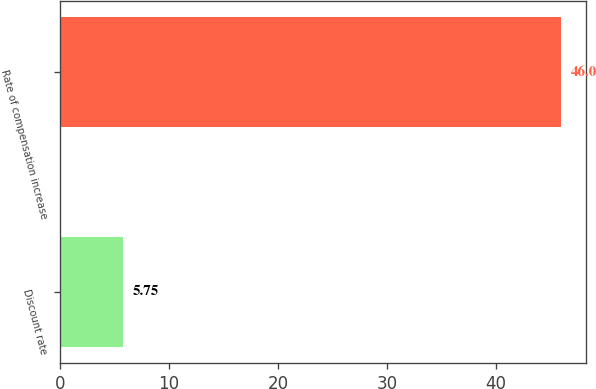<chart> <loc_0><loc_0><loc_500><loc_500><bar_chart><fcel>Discount rate<fcel>Rate of compensation increase<nl><fcel>5.75<fcel>46<nl></chart> 